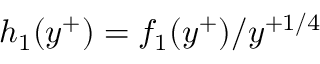<formula> <loc_0><loc_0><loc_500><loc_500>{ h } _ { 1 } ( y ^ { + } ) = f _ { 1 } ( y ^ { + } ) / y ^ { + 1 / 4 }</formula> 